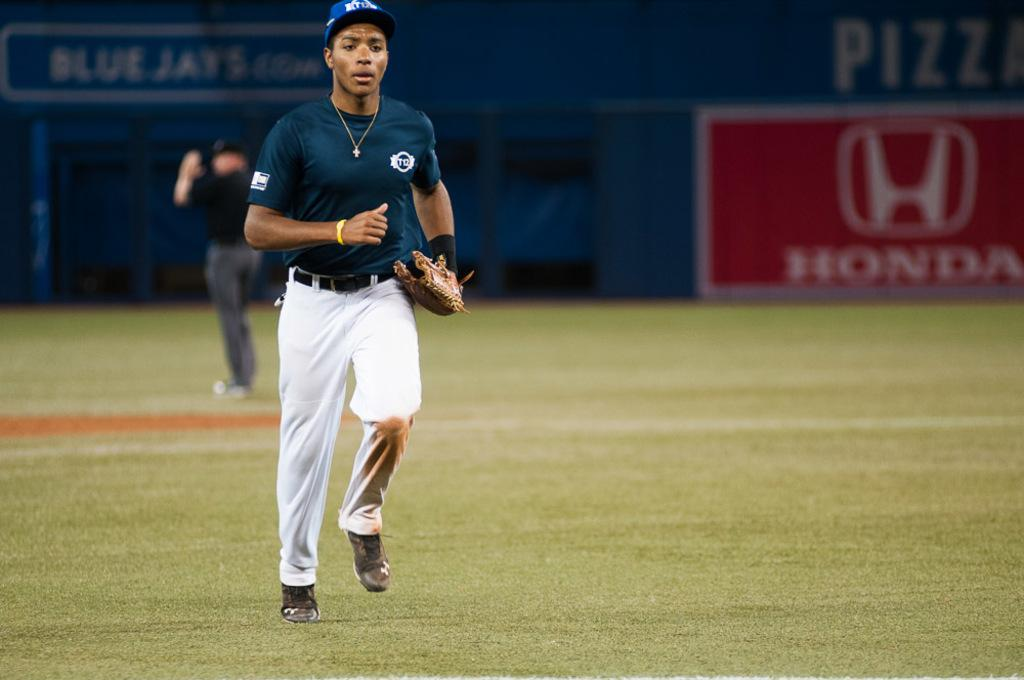Provide a one-sentence caption for the provided image. A baseball player is on the field in front of a Honda sign. 